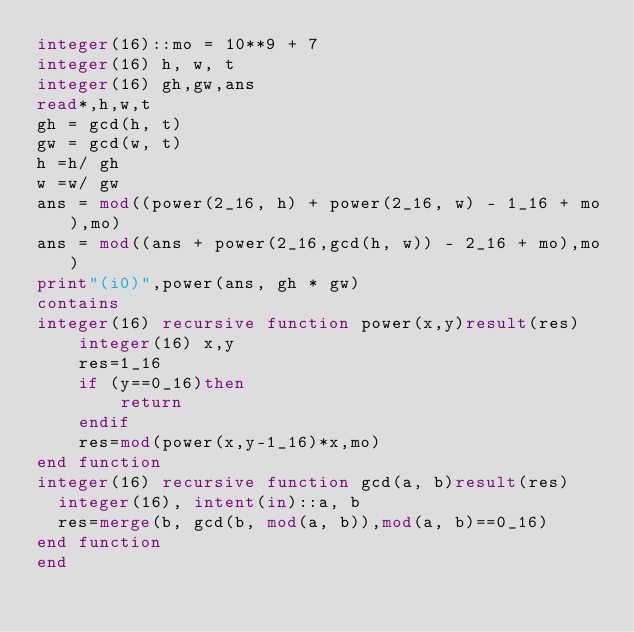Convert code to text. <code><loc_0><loc_0><loc_500><loc_500><_FORTRAN_>integer(16)::mo = 10**9 + 7
integer(16) h, w, t
integer(16) gh,gw,ans
read*,h,w,t
gh = gcd(h, t)
gw = gcd(w, t)
h =h/ gh
w =w/ gw
ans = mod((power(2_16, h) + power(2_16, w) - 1_16 + mo),mo)
ans = mod((ans + power(2_16,gcd(h, w)) - 2_16 + mo),mo) 
print"(i0)",power(ans, gh * gw)
contains
integer(16) recursive function power(x,y)result(res)
    integer(16) x,y
    res=1_16
    if (y==0_16)then
        return
    endif
    res=mod(power(x,y-1_16)*x,mo)
end function
integer(16) recursive function gcd(a, b)result(res)
  integer(16), intent(in)::a, b
  res=merge(b, gcd(b, mod(a, b)),mod(a, b)==0_16)
end function
end </code> 